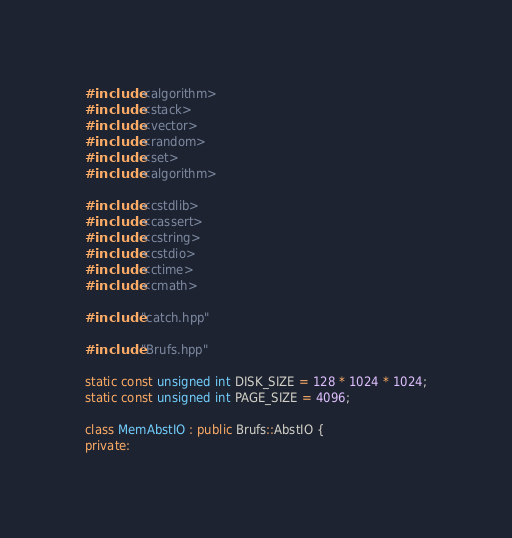Convert code to text. <code><loc_0><loc_0><loc_500><loc_500><_C++_>#include <algorithm>
#include <stack>
#include <vector>
#include <random>
#include <set>
#include <algorithm>

#include <cstdlib>
#include <cassert>
#include <cstring>
#include <cstdio>
#include <ctime>
#include <cmath>

#include "catch.hpp"

#include "Brufs.hpp"

static const unsigned int DISK_SIZE = 128 * 1024 * 1024;
static const unsigned int PAGE_SIZE = 4096;

class MemAbstIO : public Brufs::AbstIO {
private:</code> 